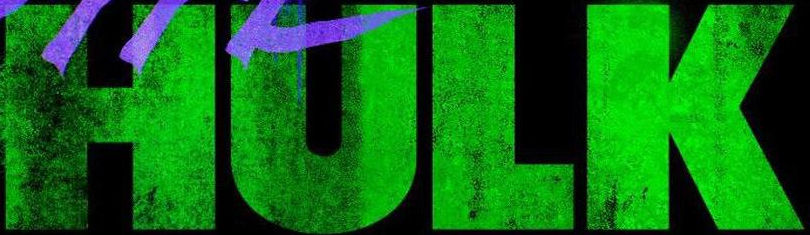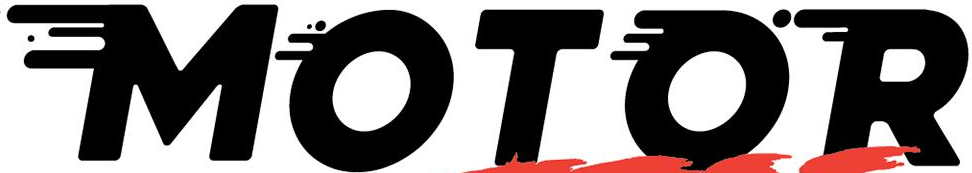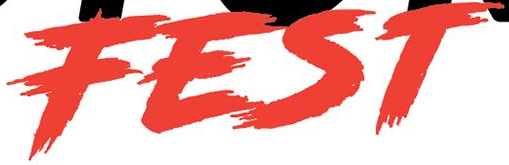What text is displayed in these images sequentially, separated by a semicolon? HULK; MOTOR; FEST 